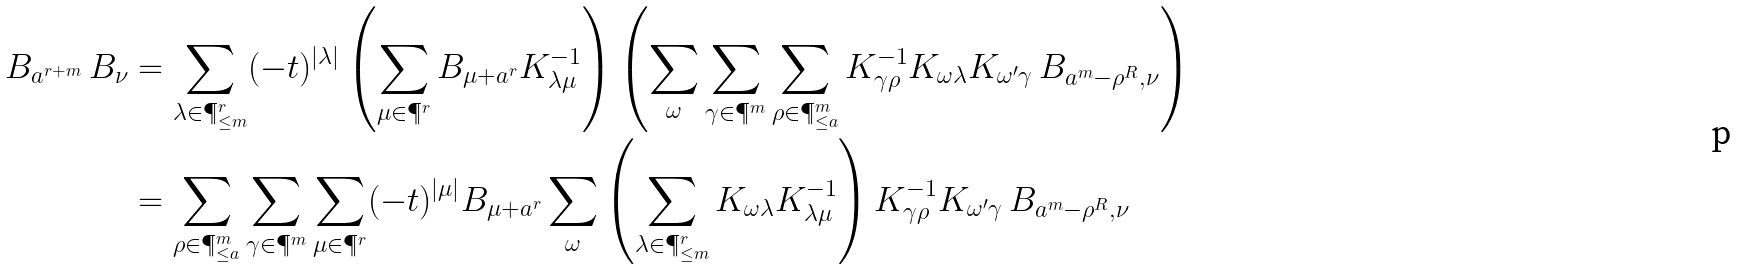<formula> <loc_0><loc_0><loc_500><loc_500>B _ { a ^ { r + m } } \, B _ { \nu } & = \sum _ { \lambda \in \P ^ { r } _ { \leq m } } ( - t ) ^ { | \lambda | } \left ( \sum _ { \mu \in \P ^ { r } } B _ { \mu + a ^ { r } } K _ { \lambda \mu } ^ { - 1 } \right ) \left ( \sum _ { \omega } \sum _ { \gamma \in \P ^ { m } } \sum _ { \rho \in \P ^ { m } _ { \leq a } } K _ { \gamma \rho } ^ { - 1 } K _ { \omega \lambda } K _ { \omega ^ { \prime } \gamma } \, B _ { a ^ { m } - \rho ^ { R } , \nu } \right ) \\ & = \sum _ { \rho \in \P ^ { m } _ { \leq a } } \sum _ { \gamma \in \P ^ { m } } \sum _ { \mu \in \P ^ { r } } ( - t ) ^ { | \mu | } B _ { \mu + a ^ { r } } \sum _ { \omega } \left ( \sum _ { \lambda \in \P ^ { r } _ { \leq m } } K _ { \omega \lambda } K _ { \lambda \mu } ^ { - 1 } \right ) K _ { \gamma \rho } ^ { - 1 } K _ { \omega ^ { \prime } \gamma } \, B _ { a ^ { m } - \rho ^ { R } , \nu } \\</formula> 